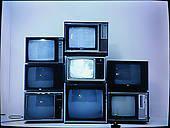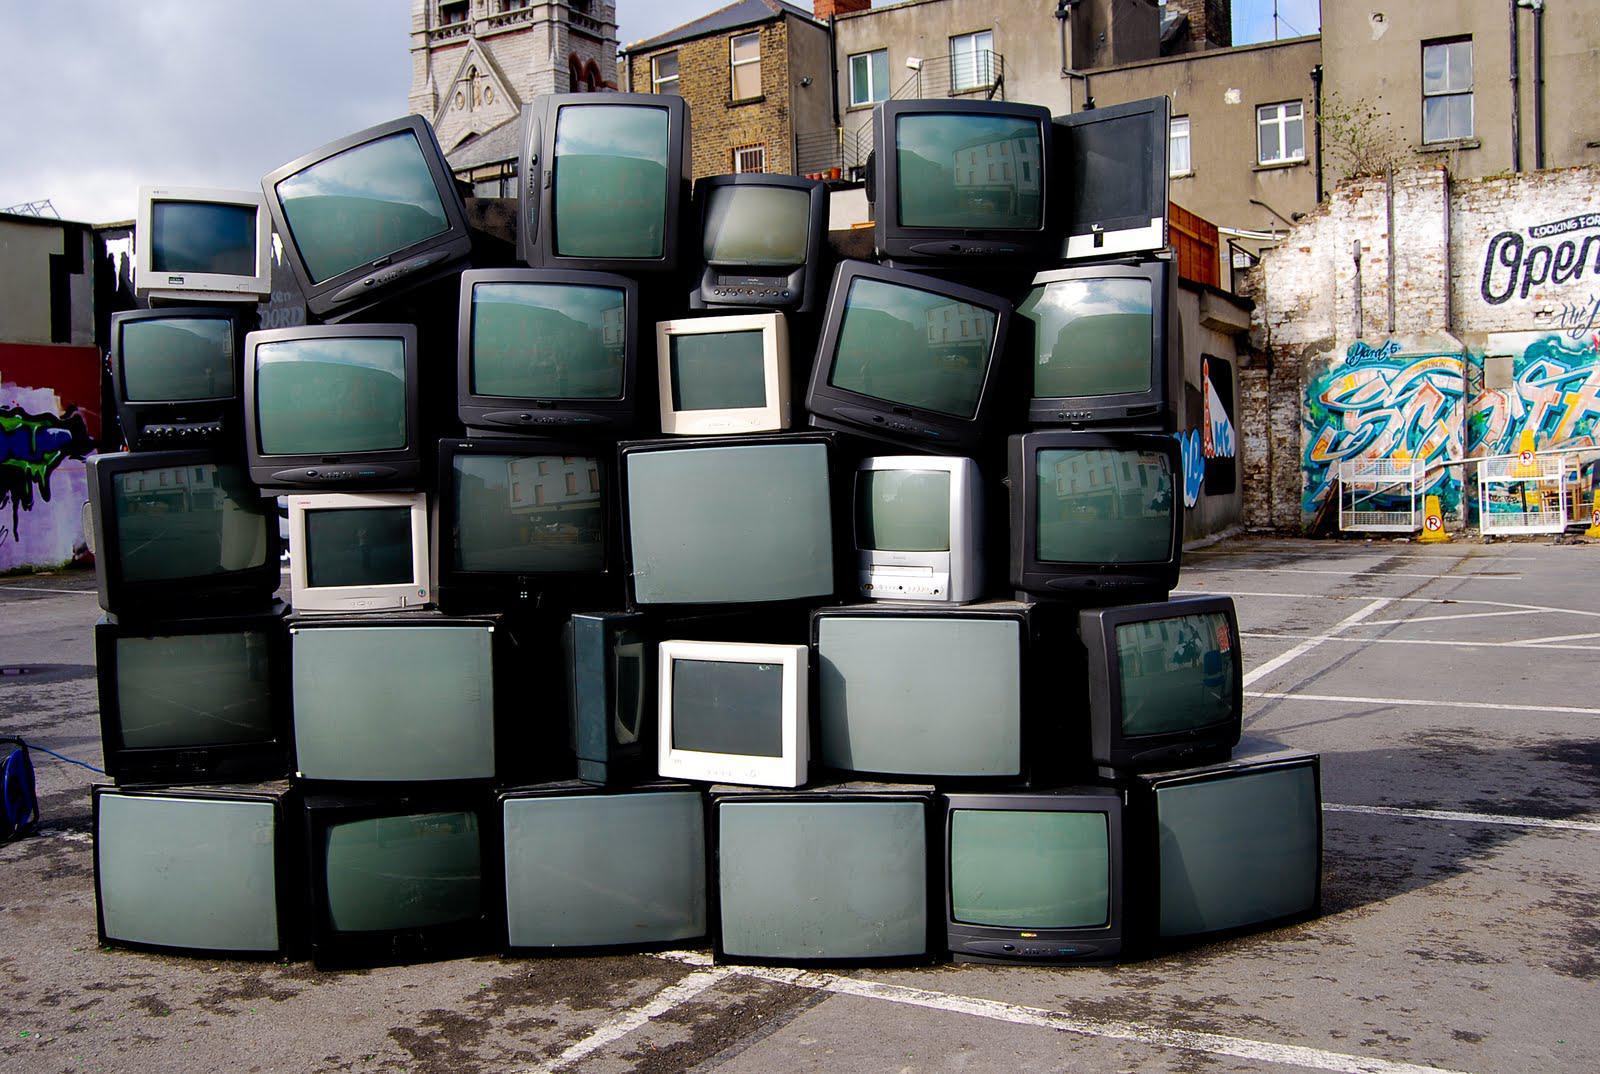The first image is the image on the left, the second image is the image on the right. For the images shown, is this caption "There are no more than 5 and no less than 2 televisions in a single image." true? Answer yes or no. No. The first image is the image on the left, the second image is the image on the right. Evaluate the accuracy of this statement regarding the images: "There are no more than 5 televisions in the right image.". Is it true? Answer yes or no. No. 